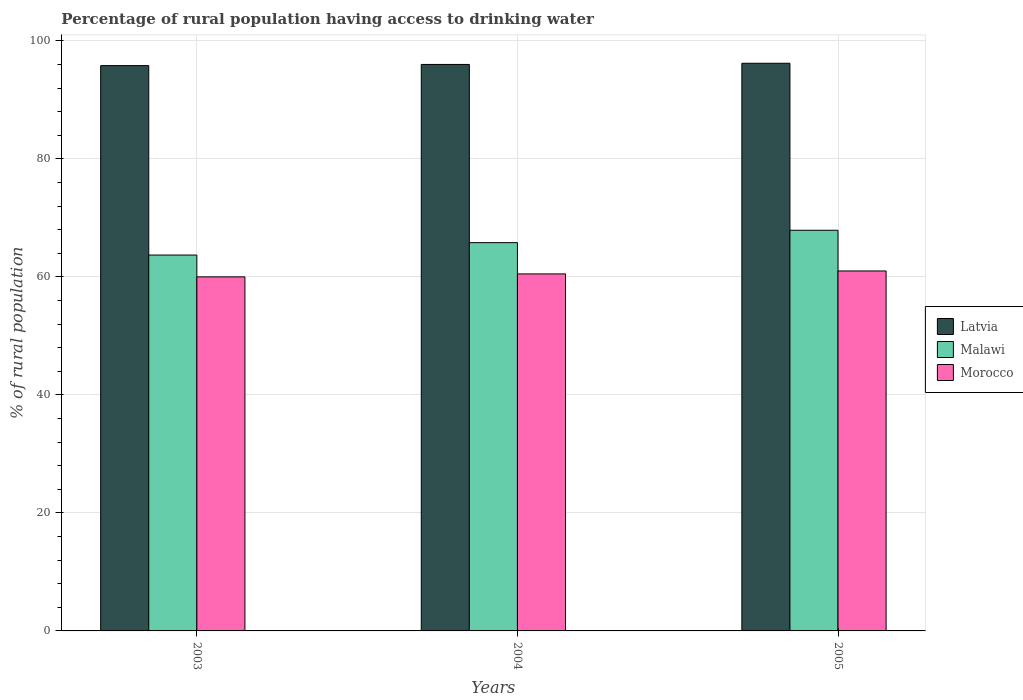Are the number of bars per tick equal to the number of legend labels?
Make the answer very short. Yes. How many bars are there on the 1st tick from the right?
Make the answer very short. 3. What is the percentage of rural population having access to drinking water in Malawi in 2003?
Offer a terse response. 63.7. Across all years, what is the minimum percentage of rural population having access to drinking water in Latvia?
Give a very brief answer. 95.8. What is the total percentage of rural population having access to drinking water in Malawi in the graph?
Provide a succinct answer. 197.4. What is the difference between the percentage of rural population having access to drinking water in Morocco in 2003 and the percentage of rural population having access to drinking water in Latvia in 2004?
Your answer should be very brief. -36. What is the average percentage of rural population having access to drinking water in Morocco per year?
Your response must be concise. 60.5. In the year 2003, what is the difference between the percentage of rural population having access to drinking water in Morocco and percentage of rural population having access to drinking water in Malawi?
Your response must be concise. -3.7. In how many years, is the percentage of rural population having access to drinking water in Morocco greater than 4 %?
Keep it short and to the point. 3. What is the ratio of the percentage of rural population having access to drinking water in Malawi in 2003 to that in 2005?
Keep it short and to the point. 0.94. Is the difference between the percentage of rural population having access to drinking water in Morocco in 2004 and 2005 greater than the difference between the percentage of rural population having access to drinking water in Malawi in 2004 and 2005?
Give a very brief answer. Yes. What is the difference between the highest and the second highest percentage of rural population having access to drinking water in Malawi?
Provide a short and direct response. 2.1. What is the difference between the highest and the lowest percentage of rural population having access to drinking water in Malawi?
Give a very brief answer. 4.2. In how many years, is the percentage of rural population having access to drinking water in Malawi greater than the average percentage of rural population having access to drinking water in Malawi taken over all years?
Your answer should be very brief. 1. Is the sum of the percentage of rural population having access to drinking water in Malawi in 2003 and 2004 greater than the maximum percentage of rural population having access to drinking water in Morocco across all years?
Keep it short and to the point. Yes. What does the 3rd bar from the left in 2005 represents?
Your answer should be compact. Morocco. What does the 1st bar from the right in 2003 represents?
Ensure brevity in your answer.  Morocco. How many bars are there?
Keep it short and to the point. 9. How many years are there in the graph?
Offer a very short reply. 3. What is the difference between two consecutive major ticks on the Y-axis?
Your answer should be compact. 20. Does the graph contain any zero values?
Provide a succinct answer. No. Does the graph contain grids?
Give a very brief answer. Yes. Where does the legend appear in the graph?
Your answer should be very brief. Center right. How many legend labels are there?
Offer a very short reply. 3. What is the title of the graph?
Make the answer very short. Percentage of rural population having access to drinking water. What is the label or title of the Y-axis?
Your response must be concise. % of rural population. What is the % of rural population of Latvia in 2003?
Ensure brevity in your answer.  95.8. What is the % of rural population of Malawi in 2003?
Your response must be concise. 63.7. What is the % of rural population in Latvia in 2004?
Your answer should be very brief. 96. What is the % of rural population of Malawi in 2004?
Your answer should be compact. 65.8. What is the % of rural population in Morocco in 2004?
Your response must be concise. 60.5. What is the % of rural population in Latvia in 2005?
Provide a short and direct response. 96.2. What is the % of rural population in Malawi in 2005?
Make the answer very short. 67.9. Across all years, what is the maximum % of rural population in Latvia?
Provide a short and direct response. 96.2. Across all years, what is the maximum % of rural population in Malawi?
Give a very brief answer. 67.9. Across all years, what is the minimum % of rural population in Latvia?
Make the answer very short. 95.8. Across all years, what is the minimum % of rural population in Malawi?
Your response must be concise. 63.7. Across all years, what is the minimum % of rural population in Morocco?
Make the answer very short. 60. What is the total % of rural population in Latvia in the graph?
Provide a short and direct response. 288. What is the total % of rural population of Malawi in the graph?
Provide a succinct answer. 197.4. What is the total % of rural population in Morocco in the graph?
Provide a succinct answer. 181.5. What is the difference between the % of rural population of Latvia in 2003 and that in 2004?
Provide a short and direct response. -0.2. What is the difference between the % of rural population in Morocco in 2003 and that in 2004?
Your response must be concise. -0.5. What is the difference between the % of rural population in Latvia in 2003 and that in 2005?
Offer a very short reply. -0.4. What is the difference between the % of rural population of Morocco in 2003 and that in 2005?
Provide a succinct answer. -1. What is the difference between the % of rural population in Latvia in 2003 and the % of rural population in Morocco in 2004?
Make the answer very short. 35.3. What is the difference between the % of rural population in Latvia in 2003 and the % of rural population in Malawi in 2005?
Provide a short and direct response. 27.9. What is the difference between the % of rural population in Latvia in 2003 and the % of rural population in Morocco in 2005?
Keep it short and to the point. 34.8. What is the difference between the % of rural population in Latvia in 2004 and the % of rural population in Malawi in 2005?
Your answer should be very brief. 28.1. What is the difference between the % of rural population of Latvia in 2004 and the % of rural population of Morocco in 2005?
Offer a terse response. 35. What is the average % of rural population of Latvia per year?
Your answer should be very brief. 96. What is the average % of rural population in Malawi per year?
Give a very brief answer. 65.8. What is the average % of rural population in Morocco per year?
Your answer should be very brief. 60.5. In the year 2003, what is the difference between the % of rural population of Latvia and % of rural population of Malawi?
Your answer should be very brief. 32.1. In the year 2003, what is the difference between the % of rural population of Latvia and % of rural population of Morocco?
Give a very brief answer. 35.8. In the year 2004, what is the difference between the % of rural population of Latvia and % of rural population of Malawi?
Ensure brevity in your answer.  30.2. In the year 2004, what is the difference between the % of rural population of Latvia and % of rural population of Morocco?
Keep it short and to the point. 35.5. In the year 2005, what is the difference between the % of rural population in Latvia and % of rural population in Malawi?
Keep it short and to the point. 28.3. In the year 2005, what is the difference between the % of rural population in Latvia and % of rural population in Morocco?
Keep it short and to the point. 35.2. In the year 2005, what is the difference between the % of rural population of Malawi and % of rural population of Morocco?
Your answer should be very brief. 6.9. What is the ratio of the % of rural population in Latvia in 2003 to that in 2004?
Provide a succinct answer. 1. What is the ratio of the % of rural population of Malawi in 2003 to that in 2004?
Your response must be concise. 0.97. What is the ratio of the % of rural population in Morocco in 2003 to that in 2004?
Provide a short and direct response. 0.99. What is the ratio of the % of rural population of Malawi in 2003 to that in 2005?
Provide a short and direct response. 0.94. What is the ratio of the % of rural population of Morocco in 2003 to that in 2005?
Provide a succinct answer. 0.98. What is the ratio of the % of rural population in Latvia in 2004 to that in 2005?
Give a very brief answer. 1. What is the ratio of the % of rural population in Malawi in 2004 to that in 2005?
Make the answer very short. 0.97. What is the difference between the highest and the second highest % of rural population in Latvia?
Make the answer very short. 0.2. What is the difference between the highest and the second highest % of rural population in Malawi?
Provide a succinct answer. 2.1. What is the difference between the highest and the lowest % of rural population of Latvia?
Ensure brevity in your answer.  0.4. What is the difference between the highest and the lowest % of rural population of Malawi?
Your answer should be compact. 4.2. What is the difference between the highest and the lowest % of rural population in Morocco?
Make the answer very short. 1. 